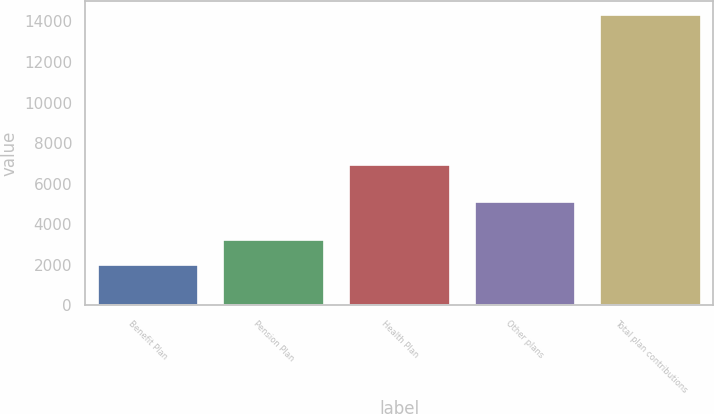Convert chart. <chart><loc_0><loc_0><loc_500><loc_500><bar_chart><fcel>Benefit Plan<fcel>Pension Plan<fcel>Health Plan<fcel>Other plans<fcel>Total plan contributions<nl><fcel>2011<fcel>3239.3<fcel>6919<fcel>5111<fcel>14294<nl></chart> 